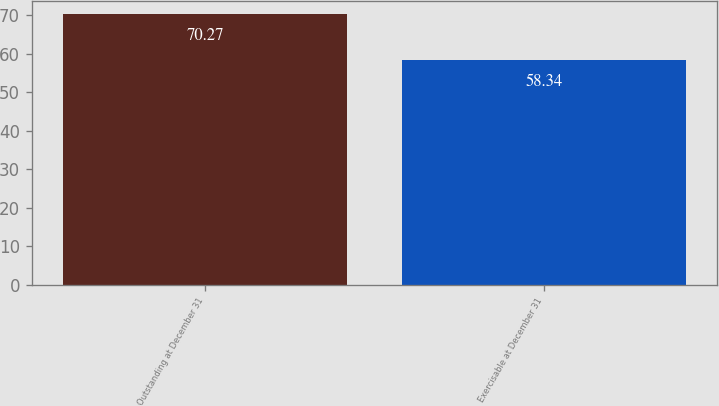Convert chart. <chart><loc_0><loc_0><loc_500><loc_500><bar_chart><fcel>Outstanding at December 31<fcel>Exercisable at December 31<nl><fcel>70.27<fcel>58.34<nl></chart> 